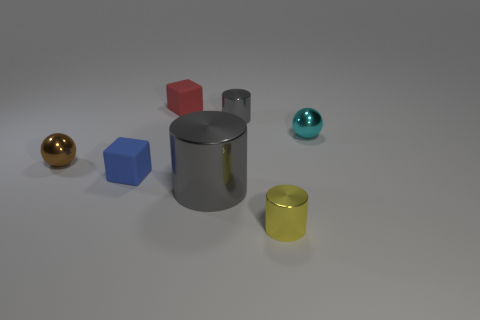Add 2 tiny blue matte blocks. How many objects exist? 9 Subtract all blocks. How many objects are left? 5 Add 5 tiny cyan shiny blocks. How many tiny cyan shiny blocks exist? 5 Subtract 0 yellow balls. How many objects are left? 7 Subtract all gray objects. Subtract all small gray metal objects. How many objects are left? 4 Add 6 big gray metal cylinders. How many big gray metal cylinders are left? 7 